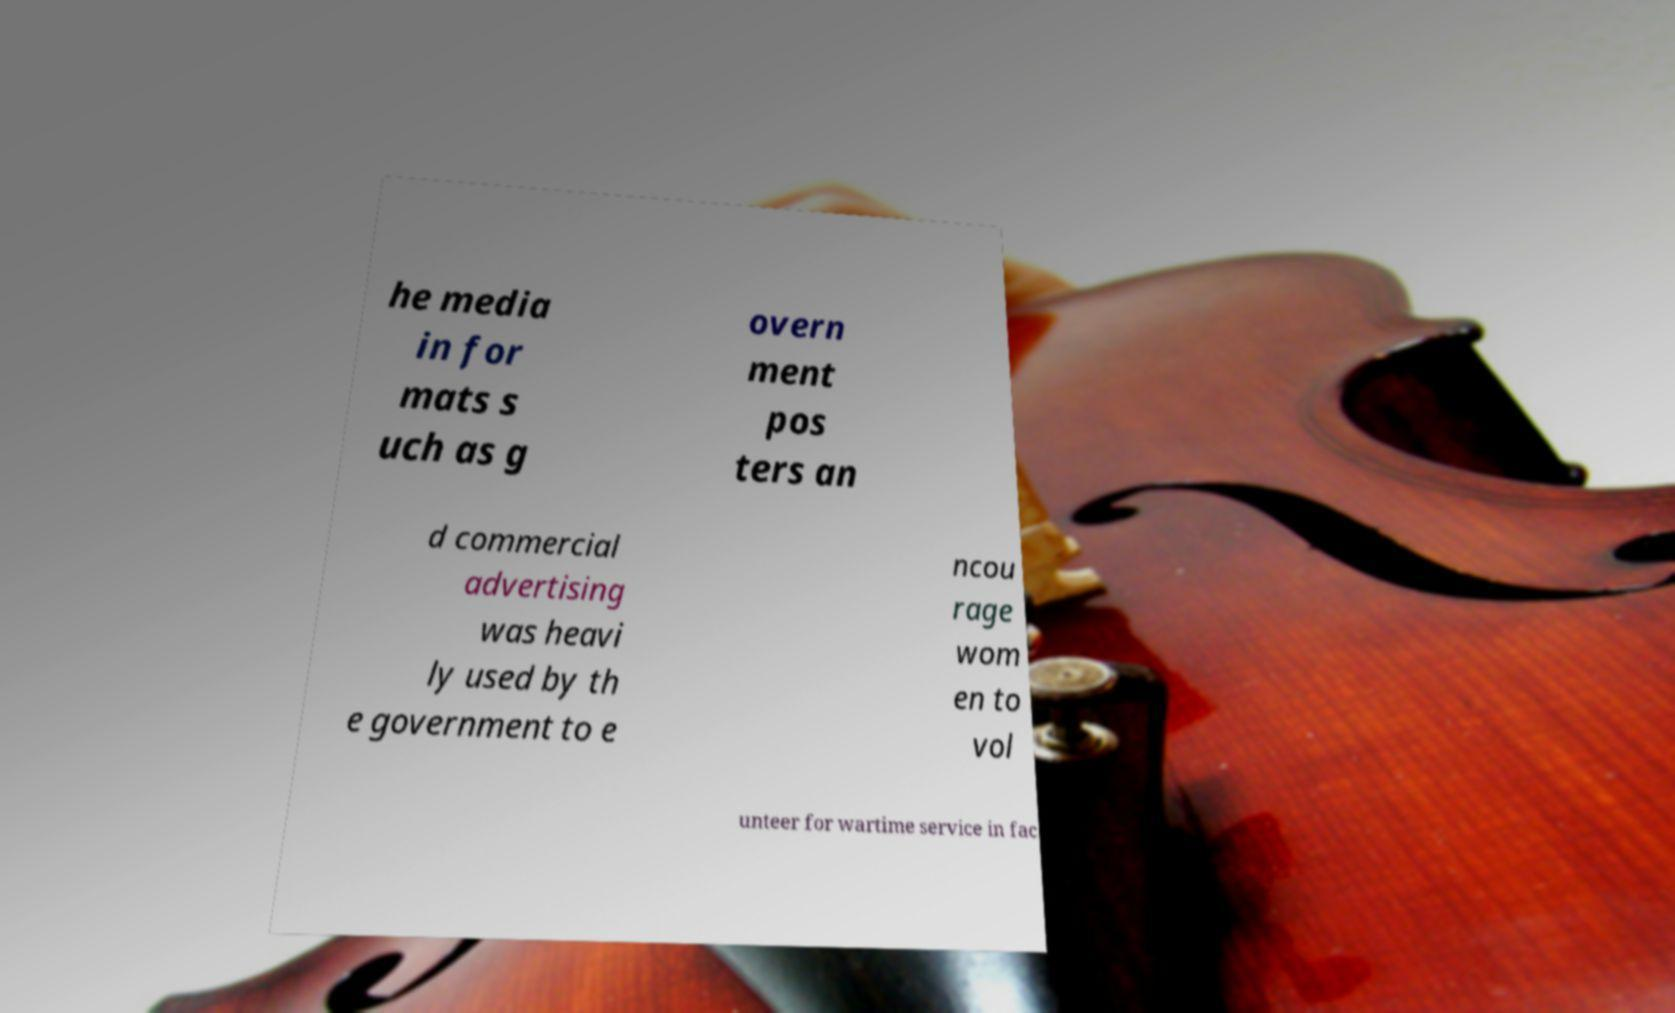Can you read and provide the text displayed in the image?This photo seems to have some interesting text. Can you extract and type it out for me? he media in for mats s uch as g overn ment pos ters an d commercial advertising was heavi ly used by th e government to e ncou rage wom en to vol unteer for wartime service in fac 